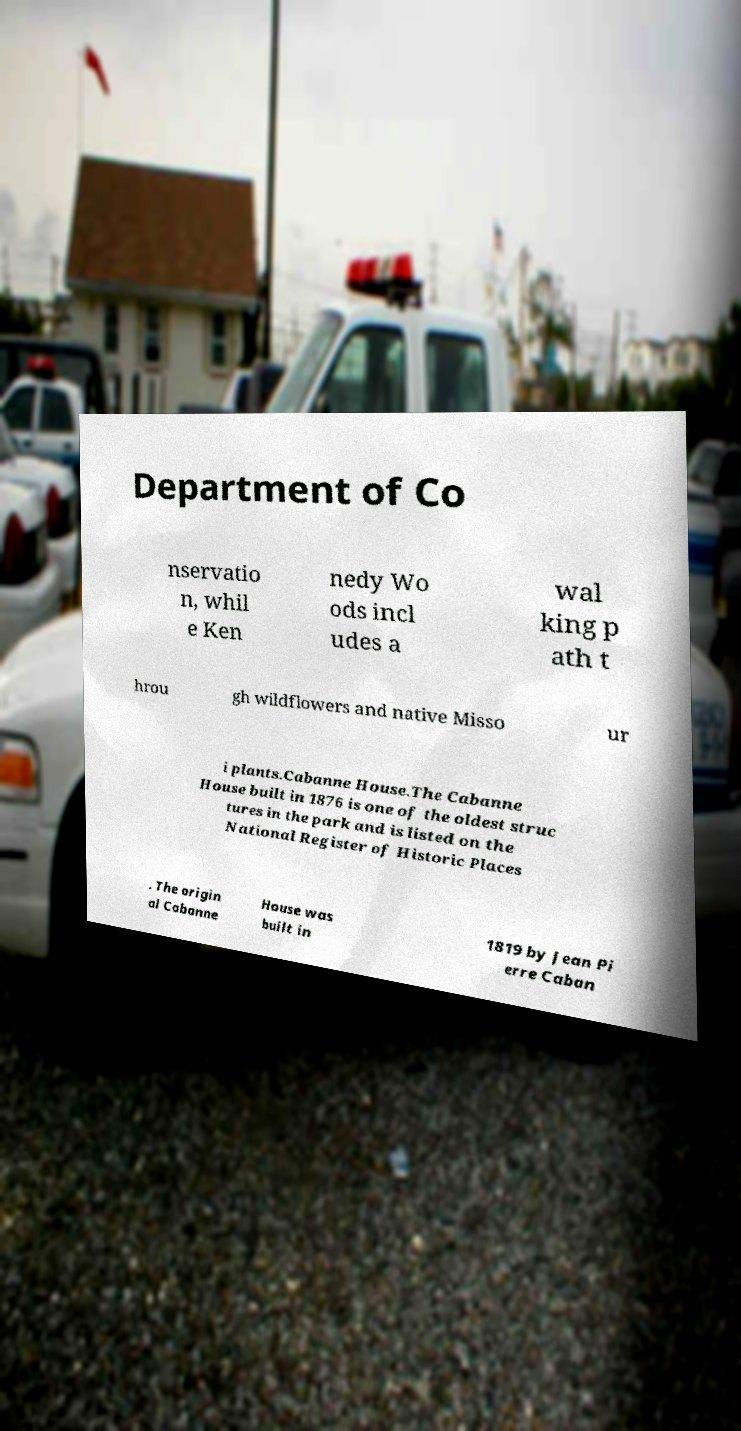Please identify and transcribe the text found in this image. Department of Co nservatio n, whil e Ken nedy Wo ods incl udes a wal king p ath t hrou gh wildflowers and native Misso ur i plants.Cabanne House.The Cabanne House built in 1876 is one of the oldest struc tures in the park and is listed on the National Register of Historic Places . The origin al Cabanne House was built in 1819 by Jean Pi erre Caban 